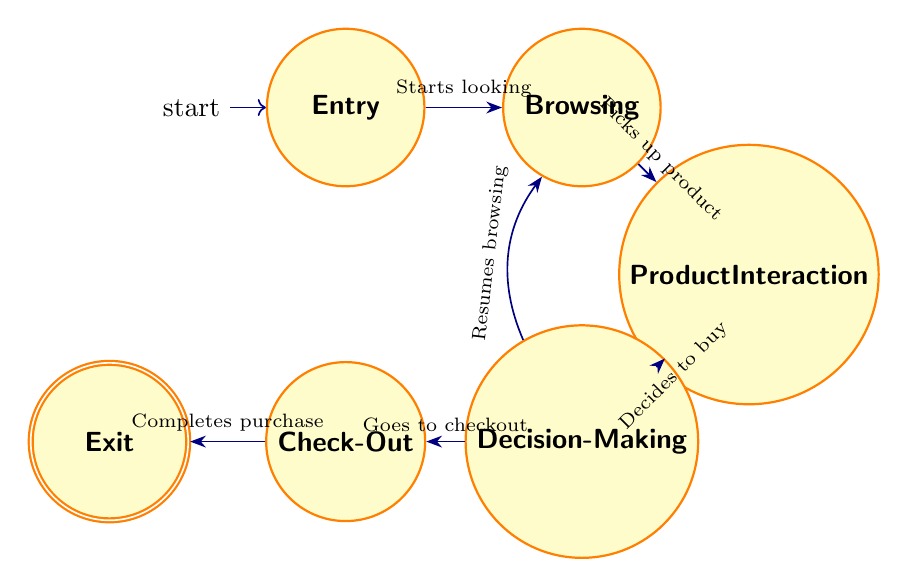What is the starting state of the customer journey? The starting state, represented by the initial node in the diagram, is labeled "Entry," indicating where the customer begins their journey in the store.
Answer: Entry How many states are depicted in the diagram? By counting all the nodes present in the diagram, including Entry, Browsing, Product Interaction, Decision-Making, Check-Out, and Exit, we find there are a total of six states.
Answer: 6 What transition occurs after "Browsing"? The transition from "Browsing" occurs when the customer picks up a product for closer inspection, leading to the "Product Interaction" state as indicated by the labeled arrow in the diagram.
Answer: Product Interaction From "Decision-Making," what is a possible action a customer can take? In the "Decision-Making" state, the customer can either decide to buy the product and go to "Check-Out" or choose to resume "Browsing," as shown by the interconnected transitions in the diagram.
Answer: Buy or Resume Browsing What is the final state a customer reaches after "Check-Out"? After completing the purchase at the "Check-Out" state, the customer proceeds to the end state labeled "Exit," indicating their departure from the store.
Answer: Exit Which state follows "Product Interaction" if the customer decides not to buy? If the customer decides not to purchase the product after product interaction, they will return to "Browsing," as indicated by the arrow returning to that state from "Decision-Making."
Answer: Browsing How many transitions are shown in the diagram? By counting all the directed edges present in the diagram, which connect the nodes representing the different states, we find there are a total of six transitions.
Answer: 6 What action leads from "Product Interaction" to "Decision-Making"? The action that leads from "Product Interaction" to "Decision-Making" is the customer's decision regarding the inspected product, signifying they are considering whether to purchase it.
Answer: Decides to buy What is the relationship between "Check-Out" and "Exit"? The relationship between "Check-Out" and "Exit" is a direct transition indicating that after completing the purchase at "Check-Out," the customer will exit the store, moving from one state to the next in the journey.
Answer: Direct transition 